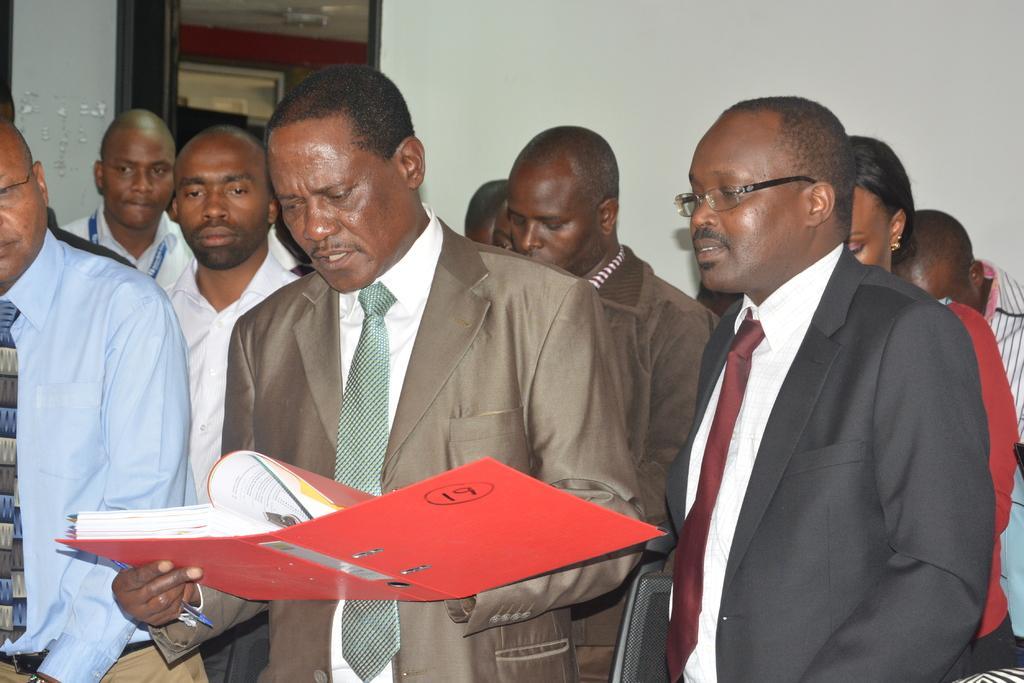Describe this image in one or two sentences. This image consists of few persons. In the front, the man is holding a book and reading. In the background, there is a wall along with window. 